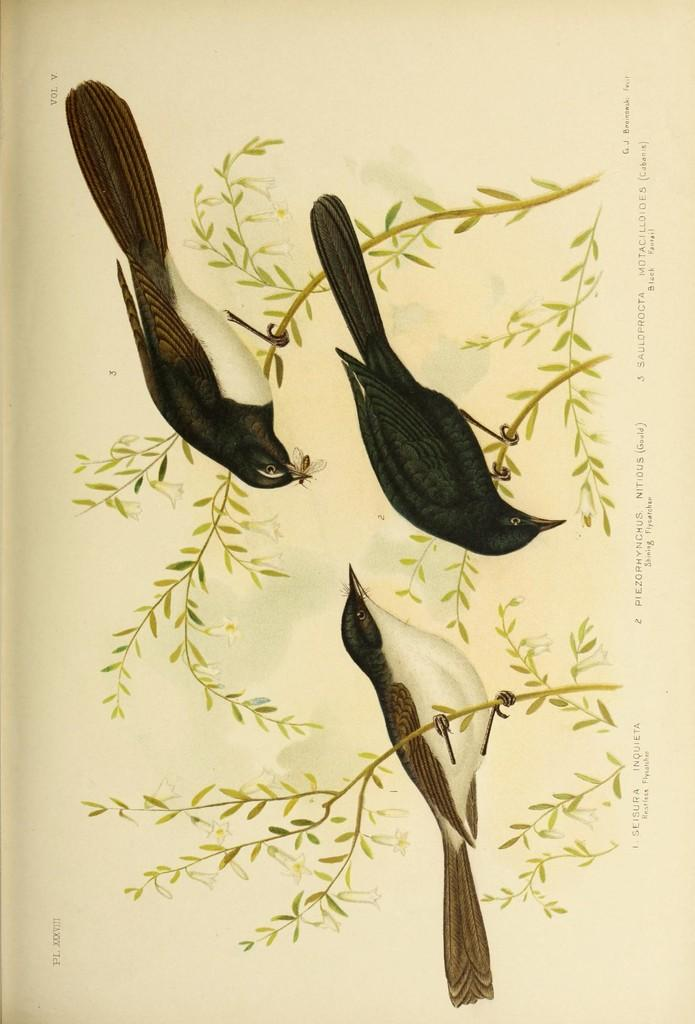What type of visual is depicted in the image? The image is a poster. What animals are featured in the poster? There are three birds in the image. What are the birds standing on? The birds are standing on stems. What other elements can be seen in the image? There are leaves in the image. What else is present on the poster besides the birds and leaves? There are letters on the poster. What type of cat can be seen climbing the stems in the image? There is no cat present in the image; it features three birds standing on stems. What route do the birds take to reach the top of the stems in the image? The image does not show the birds moving or taking a route; they are simply standing on the stems. 